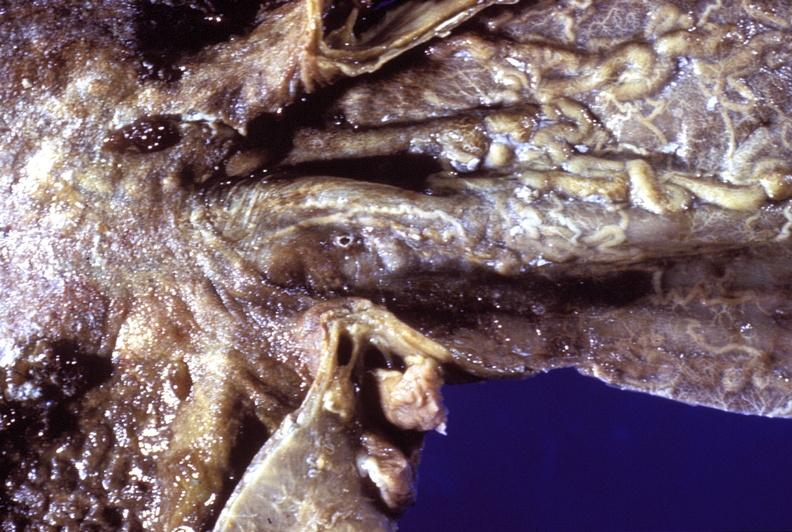where does this belong to?
Answer the question using a single word or phrase. Gastrointestinal system 